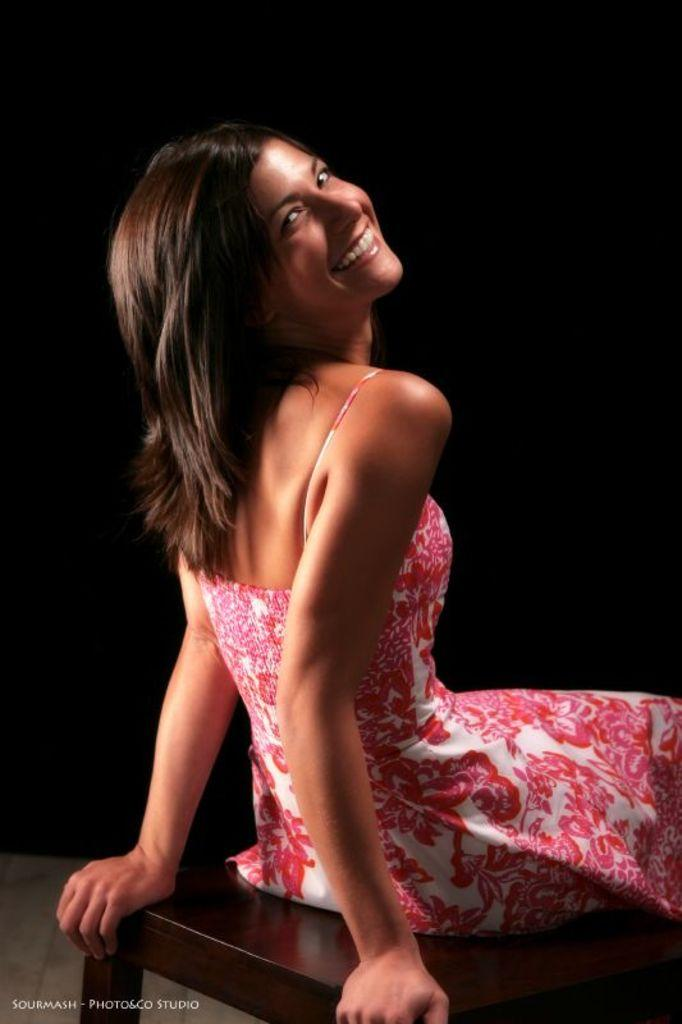Who is the main subject in the image? There is a woman in the image. What is the woman wearing? The woman is wearing a pink dress. What is the woman doing in the image? The woman is sitting on a stool. What is the woman's facial expression in the image? The woman is smiling. Can you tell me how many horses are present in the image? There are no horses present in the image; it features a woman sitting on a stool. What type of cellar can be seen in the background of the image? There is no cellar visible in the image; it is a close-up shot of a woman sitting on a stool. 